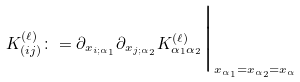Convert formula to latex. <formula><loc_0><loc_0><loc_500><loc_500>K _ { ( i j ) } ^ { ( \ell ) } \colon = \partial _ { x _ { i ; \alpha _ { 1 } } } \partial _ { x _ { j ; \alpha _ { 2 } } } K _ { \alpha _ { 1 } \alpha _ { 2 } } ^ { ( \ell ) } \Big | _ { x _ { \alpha _ { 1 } } = x _ { \alpha _ { 2 } } = x _ { \alpha } }</formula> 